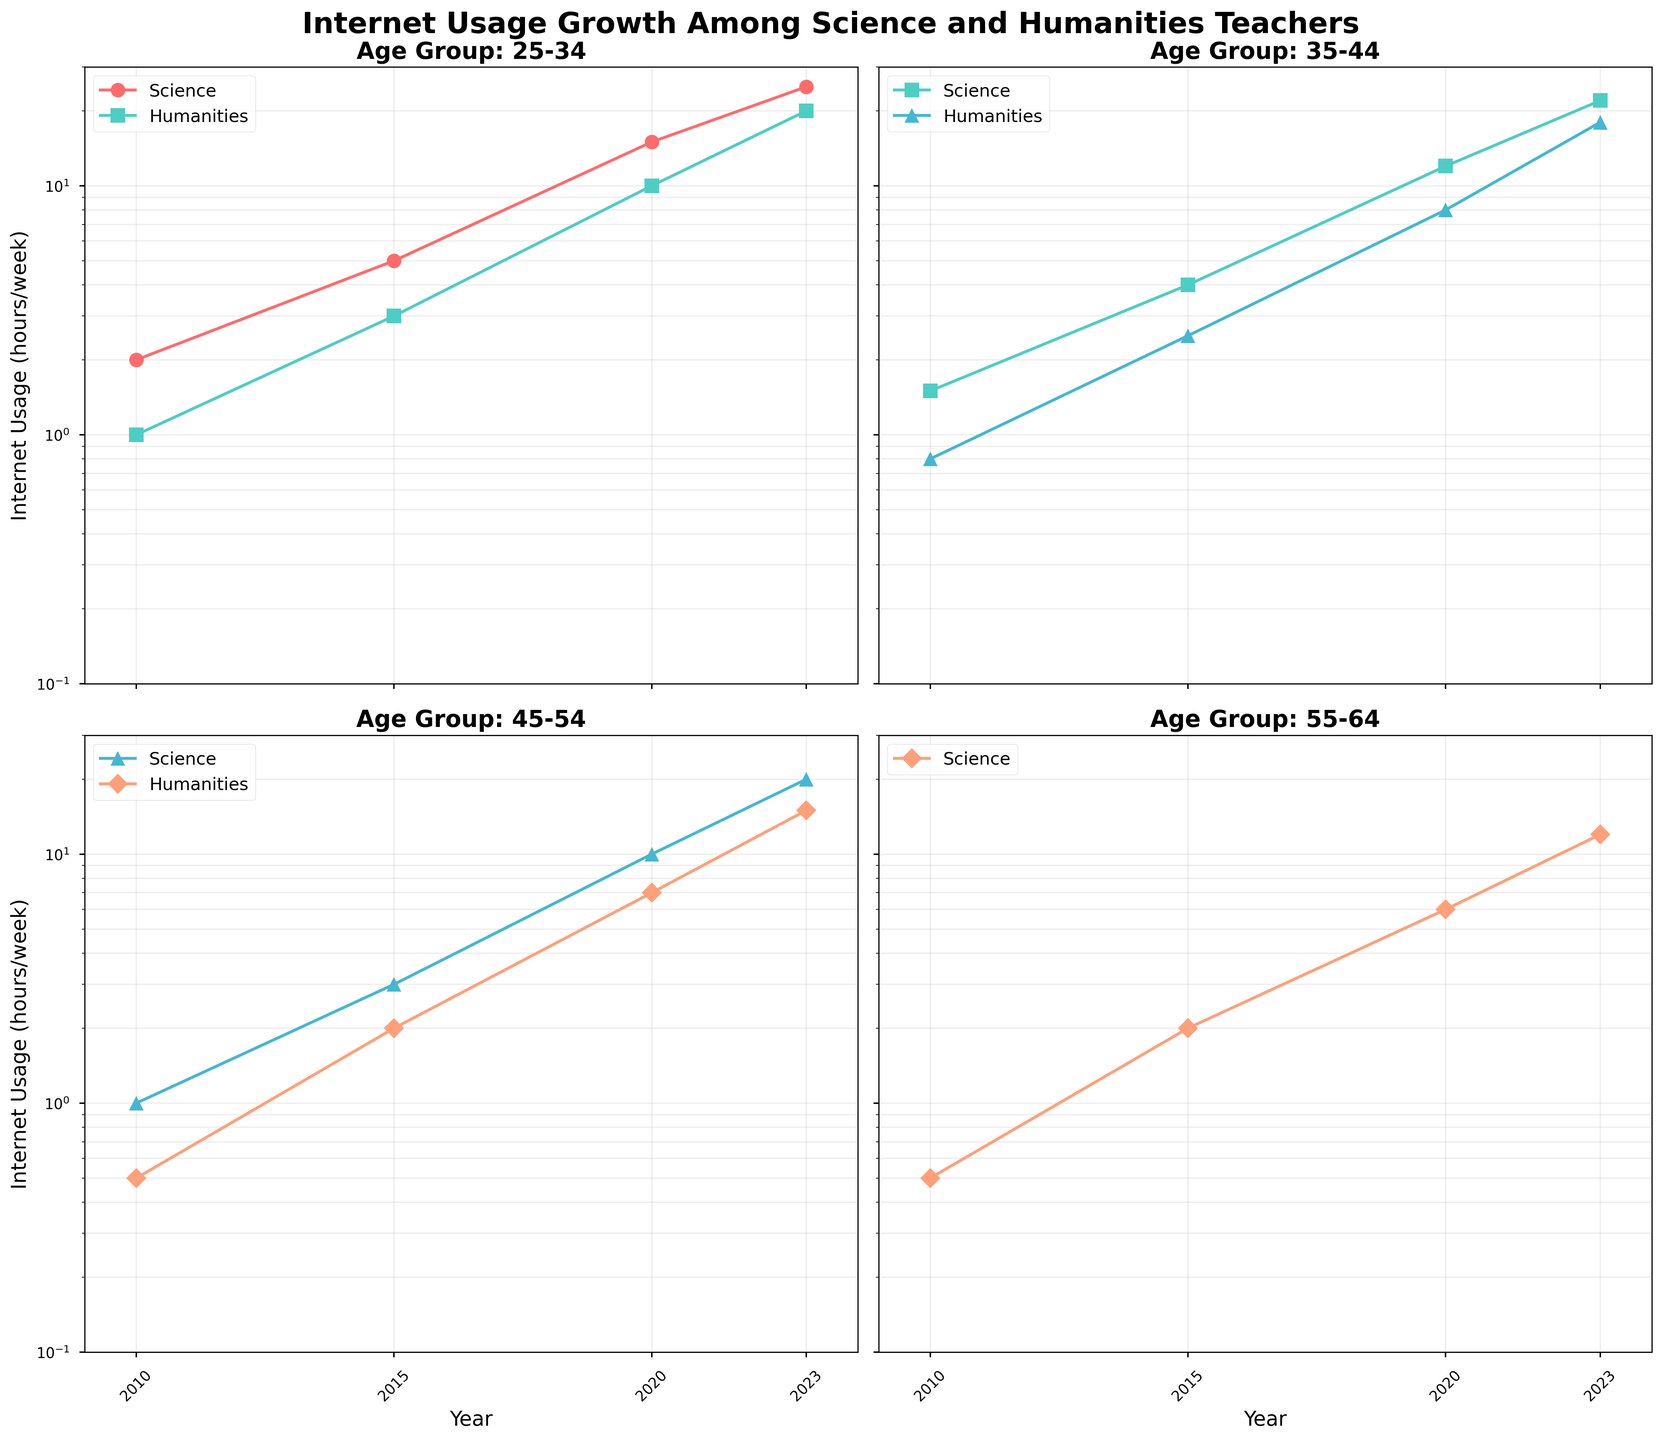What is the title of the figure? The title of the figure is displayed at the top and reads 'Internet Usage Growth Among Science and Humanities Teachers'.
Answer: Internet Usage Growth Among Science and Humanities Teachers How many subplots are there in the figure? There are four subplots, each corresponding to a different age group: 25-34, 35-44, 45-54, and 55-64.
Answer: 4 What is the internet usage of Humanities teachers in the 55-64 age group in 2010? Focusing on the subplot for the 55-64 age group, the internet usage of Humanities teachers in 2010 is at 0.3 hours/week.
Answer: 0.3 hours/week Which age group shows the highest internet usage among Science teachers in 2023? Looking at the 2023 data points for Science teachers in all age groups, the 25-34 age group shows the highest internet usage at 25 hours/week.
Answer: 25-34 How many data points are there for Science teachers in the 45-54 age group? The 45-54 age group subplot shows data points for the years 2010, 2015, 2020, and 2023, resulting in a total of 4 data points for Science teachers.
Answer: 4 What is the trend of internet usage for Humanities teachers in the 35-44 age group from 2010 to 2023? Observing the subplot for the 35-44 age group, the internet usage for Humanities teachers shows an increasing trend, starting at 0.8 hours/week in 2010 and reaching 18 hours/week in 2023.
Answer: Increasing trend Which teacher type has higher internet usage in the 45-54 age group in 2023? In the 45-54 age group subplot for 2023, Science teachers have higher internet usage at 20 hours/week compared to Humanities teachers at 15 hours/week.
Answer: Science teachers What is the difference in internet usage between Science and Humanities teachers in the 35-44 age group in 2023? In the 35-44 age group subplot for 2023, Science teachers have an internet usage of 22 hours/week and Humanities teachers have 18 hours/week. The difference is 22 - 18 = 4 hours/week.
Answer: 4 hours/week Calculate the average internet usage for Science teachers across all age groups in 2020. The internet usage for Science teachers in 2020 is 15 (25-34) + 12 (35-44) + 10 (45-54) + 6 (55-64). Summing these gives 43 hours/week. Dividing by 4 (age groups) yields an average of 43/4 = 10.75 hours/week.
Answer: 10.75 hours/week What is the general observation about the internet usage growth pattern on a log scale for all age groups? On the log scale, we can observe an exponential growth pattern in internet usage across all age groups and teacher types from 2010 to 2023.
Answer: Exponential growth pattern 